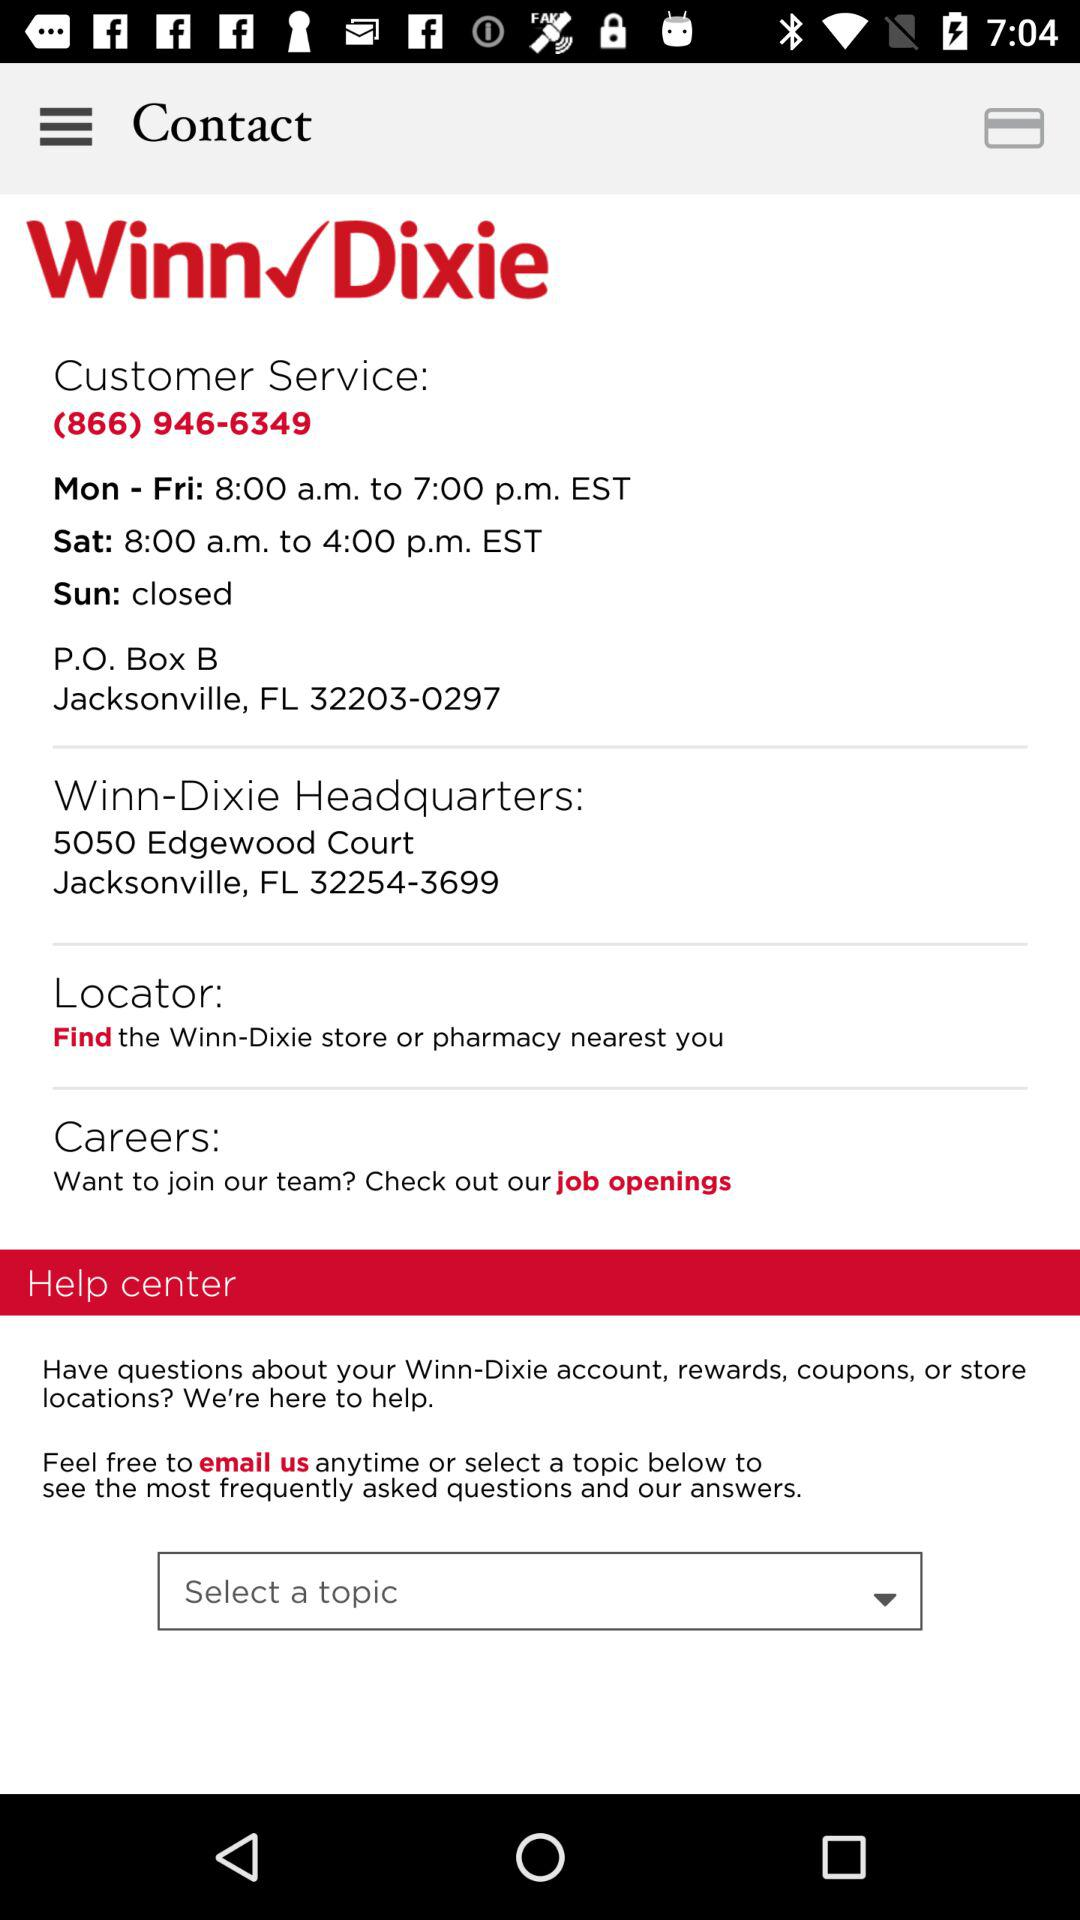What is the opening time on Saturday? The opening time on Saturday is 8:00 a.m. 